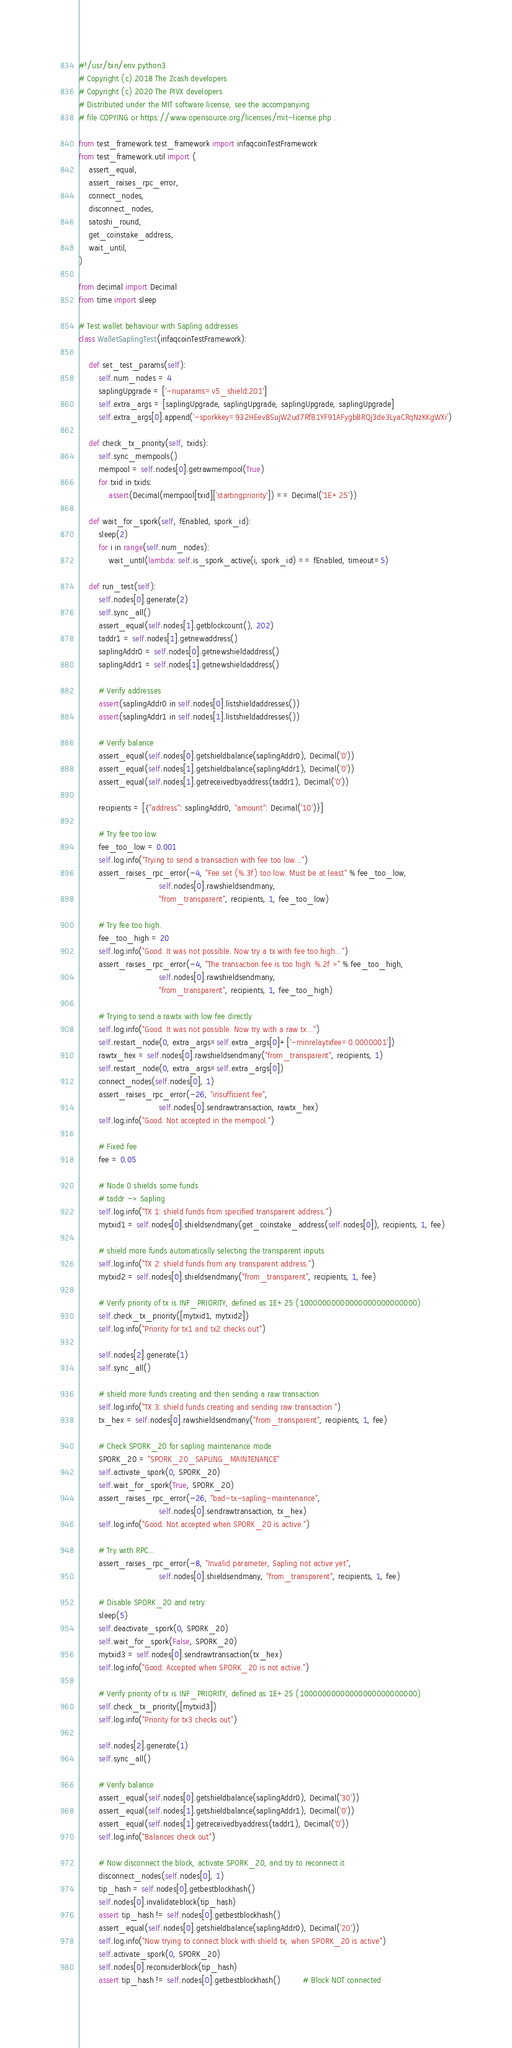Convert code to text. <code><loc_0><loc_0><loc_500><loc_500><_Python_>#!/usr/bin/env python3
# Copyright (c) 2018 The Zcash developers
# Copyright (c) 2020 The PIVX developers
# Distributed under the MIT software license, see the accompanying
# file COPYING or https://www.opensource.org/licenses/mit-license.php .

from test_framework.test_framework import infaqcoinTestFramework
from test_framework.util import (
    assert_equal,
    assert_raises_rpc_error,
    connect_nodes,
    disconnect_nodes,
    satoshi_round,
    get_coinstake_address,
    wait_until,
)

from decimal import Decimal
from time import sleep

# Test wallet behaviour with Sapling addresses
class WalletSaplingTest(infaqcoinTestFramework):

    def set_test_params(self):
        self.num_nodes = 4
        saplingUpgrade = ['-nuparams=v5_shield:201']
        self.extra_args = [saplingUpgrade, saplingUpgrade, saplingUpgrade, saplingUpgrade]
        self.extra_args[0].append('-sporkkey=932HEevBSujW2ud7RfB1YF91AFygbBRQj3de3LyaCRqNzKKgWXi')

    def check_tx_priority(self, txids):
        self.sync_mempools()
        mempool = self.nodes[0].getrawmempool(True)
        for txid in txids:
            assert(Decimal(mempool[txid]['startingpriority']) == Decimal('1E+25'))

    def wait_for_spork(self, fEnabled, spork_id):
        sleep(2)
        for i in range(self.num_nodes):
            wait_until(lambda: self.is_spork_active(i, spork_id) == fEnabled, timeout=5)

    def run_test(self):
        self.nodes[0].generate(2)
        self.sync_all()
        assert_equal(self.nodes[1].getblockcount(), 202)
        taddr1 = self.nodes[1].getnewaddress()
        saplingAddr0 = self.nodes[0].getnewshieldaddress()
        saplingAddr1 = self.nodes[1].getnewshieldaddress()

        # Verify addresses
        assert(saplingAddr0 in self.nodes[0].listshieldaddresses())
        assert(saplingAddr1 in self.nodes[1].listshieldaddresses())

        # Verify balance
        assert_equal(self.nodes[0].getshieldbalance(saplingAddr0), Decimal('0'))
        assert_equal(self.nodes[1].getshieldbalance(saplingAddr1), Decimal('0'))
        assert_equal(self.nodes[1].getreceivedbyaddress(taddr1), Decimal('0'))

        recipients = [{"address": saplingAddr0, "amount": Decimal('10')}]

        # Try fee too low
        fee_too_low = 0.001
        self.log.info("Trying to send a transaction with fee too low...")
        assert_raises_rpc_error(-4, "Fee set (%.3f) too low. Must be at least" % fee_too_low,
                                self.nodes[0].rawshieldsendmany,
                                "from_transparent", recipients, 1, fee_too_low)

        # Try fee too high.
        fee_too_high = 20
        self.log.info("Good. It was not possible. Now try a tx with fee too high...")
        assert_raises_rpc_error(-4, "The transaction fee is too high: %.2f >" % fee_too_high,
                                self.nodes[0].rawshieldsendmany,
                                "from_transparent", recipients, 1, fee_too_high)

        # Trying to send a rawtx with low fee directly
        self.log.info("Good. It was not possible. Now try with a raw tx...")
        self.restart_node(0, extra_args=self.extra_args[0]+['-minrelaytxfee=0.0000001'])
        rawtx_hex = self.nodes[0].rawshieldsendmany("from_transparent", recipients, 1)
        self.restart_node(0, extra_args=self.extra_args[0])
        connect_nodes(self.nodes[0], 1)
        assert_raises_rpc_error(-26, "insufficient fee",
                                self.nodes[0].sendrawtransaction, rawtx_hex)
        self.log.info("Good. Not accepted in the mempool.")

        # Fixed fee
        fee = 0.05

        # Node 0 shields some funds
        # taddr -> Sapling
        self.log.info("TX 1: shield funds from specified transparent address.")
        mytxid1 = self.nodes[0].shieldsendmany(get_coinstake_address(self.nodes[0]), recipients, 1, fee)

        # shield more funds automatically selecting the transparent inputs
        self.log.info("TX 2: shield funds from any transparent address.")
        mytxid2 = self.nodes[0].shieldsendmany("from_transparent", recipients, 1, fee)

        # Verify priority of tx is INF_PRIORITY, defined as 1E+25 (10000000000000000000000000)
        self.check_tx_priority([mytxid1, mytxid2])
        self.log.info("Priority for tx1 and tx2 checks out")

        self.nodes[2].generate(1)
        self.sync_all()

        # shield more funds creating and then sending a raw transaction
        self.log.info("TX 3: shield funds creating and sending raw transaction.")
        tx_hex = self.nodes[0].rawshieldsendmany("from_transparent", recipients, 1, fee)

        # Check SPORK_20 for sapling maintenance mode
        SPORK_20 = "SPORK_20_SAPLING_MAINTENANCE"
        self.activate_spork(0, SPORK_20)
        self.wait_for_spork(True, SPORK_20)
        assert_raises_rpc_error(-26, "bad-tx-sapling-maintenance",
                                self.nodes[0].sendrawtransaction, tx_hex)
        self.log.info("Good. Not accepted when SPORK_20 is active.")

        # Try with RPC...
        assert_raises_rpc_error(-8, "Invalid parameter, Sapling not active yet",
                                self.nodes[0].shieldsendmany, "from_transparent", recipients, 1, fee)

        # Disable SPORK_20 and retry
        sleep(5)
        self.deactivate_spork(0, SPORK_20)
        self.wait_for_spork(False, SPORK_20)
        mytxid3 = self.nodes[0].sendrawtransaction(tx_hex)
        self.log.info("Good. Accepted when SPORK_20 is not active.")

        # Verify priority of tx is INF_PRIORITY, defined as 1E+25 (10000000000000000000000000)
        self.check_tx_priority([mytxid3])
        self.log.info("Priority for tx3 checks out")

        self.nodes[2].generate(1)
        self.sync_all()

        # Verify balance
        assert_equal(self.nodes[0].getshieldbalance(saplingAddr0), Decimal('30'))
        assert_equal(self.nodes[1].getshieldbalance(saplingAddr1), Decimal('0'))
        assert_equal(self.nodes[1].getreceivedbyaddress(taddr1), Decimal('0'))
        self.log.info("Balances check out")

        # Now disconnect the block, activate SPORK_20, and try to reconnect it
        disconnect_nodes(self.nodes[0], 1)
        tip_hash = self.nodes[0].getbestblockhash()
        self.nodes[0].invalidateblock(tip_hash)
        assert tip_hash != self.nodes[0].getbestblockhash()
        assert_equal(self.nodes[0].getshieldbalance(saplingAddr0), Decimal('20'))
        self.log.info("Now trying to connect block with shield tx, when SPORK_20 is active")
        self.activate_spork(0, SPORK_20)
        self.nodes[0].reconsiderblock(tip_hash)
        assert tip_hash != self.nodes[0].getbestblockhash()         # Block NOT connected</code> 